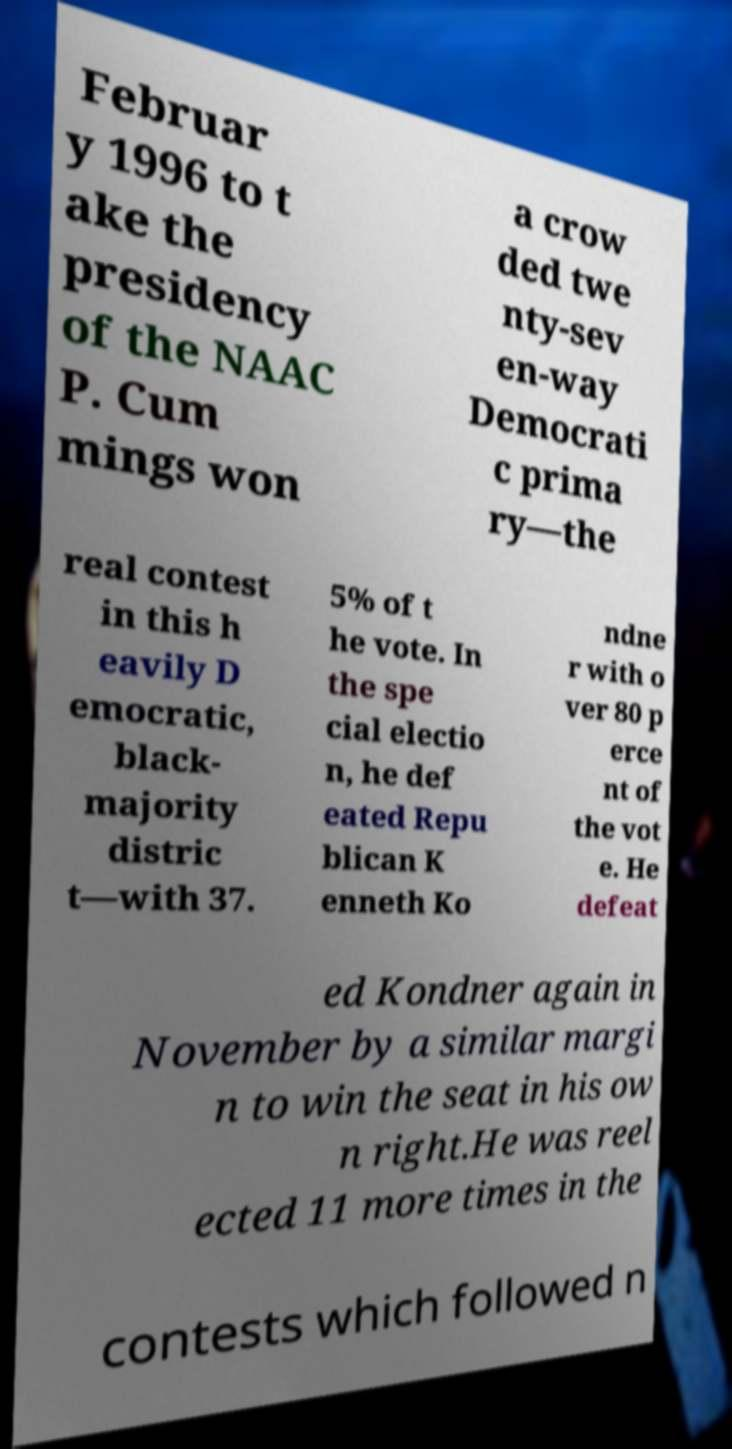Could you assist in decoding the text presented in this image and type it out clearly? Februar y 1996 to t ake the presidency of the NAAC P. Cum mings won a crow ded twe nty-sev en-way Democrati c prima ry—the real contest in this h eavily D emocratic, black- majority distric t—with 37. 5% of t he vote. In the spe cial electio n, he def eated Repu blican K enneth Ko ndne r with o ver 80 p erce nt of the vot e. He defeat ed Kondner again in November by a similar margi n to win the seat in his ow n right.He was reel ected 11 more times in the contests which followed n 